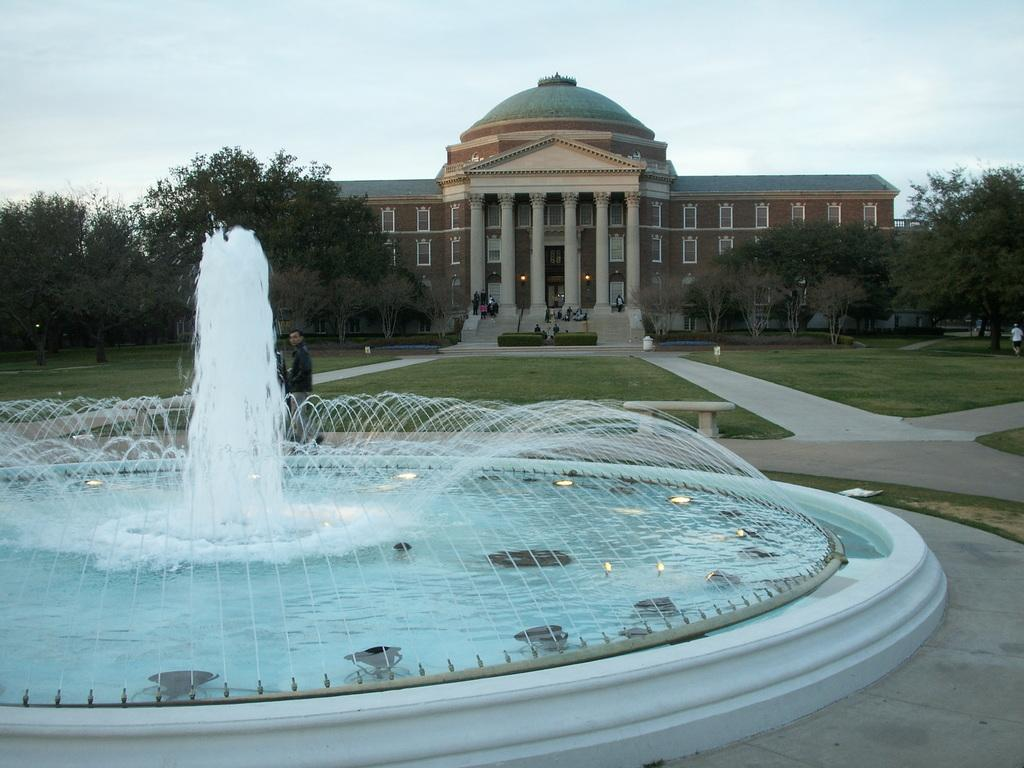What is the main feature in the image? There is a water fountain in the image. What can be seen in the image besides the water fountain? There are lights, walkways, people, grass, trees, stairs, plants, a building, walls, windows, and pillars visible in the image. What is visible in the background of the image? The sky is visible in the background of the image. What is the current temperature of the water in the fountain? The provided facts do not include information about the temperature of the water in the fountain, so it cannot be determined from the image. 